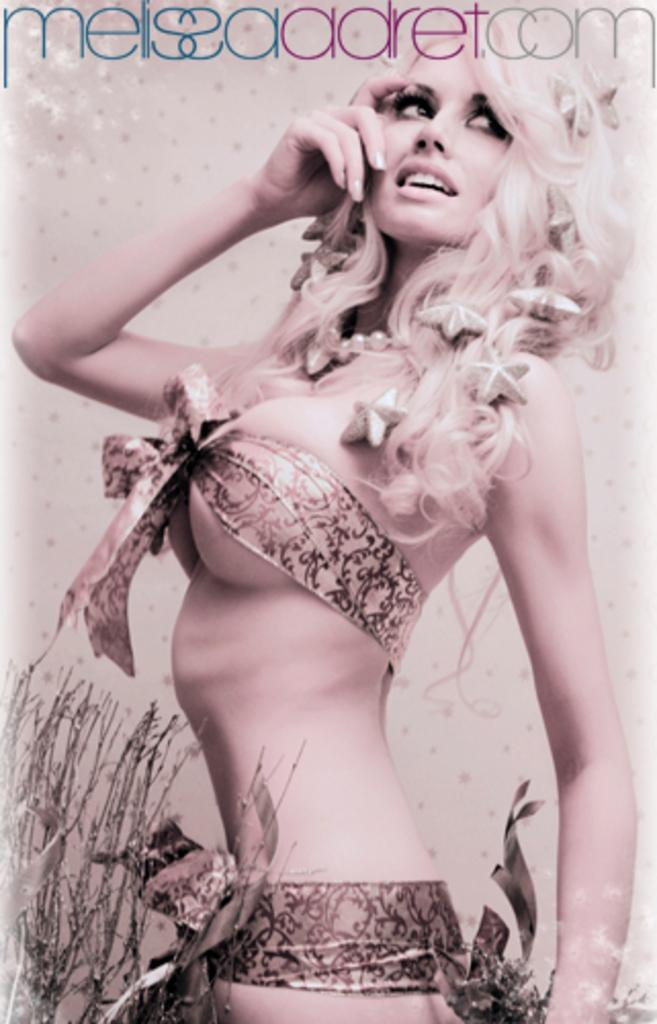Who is present in the image? There is a woman in the image. What type of vegetation can be seen in the image? There are plants in the bottom left of the image. What can be found at the top of the image? There is text visible at the top of the image. What type of pie is being served in the image? There is no pie present in the image. What type of furniture can be seen in the image? There is no furniture visible in the image. 